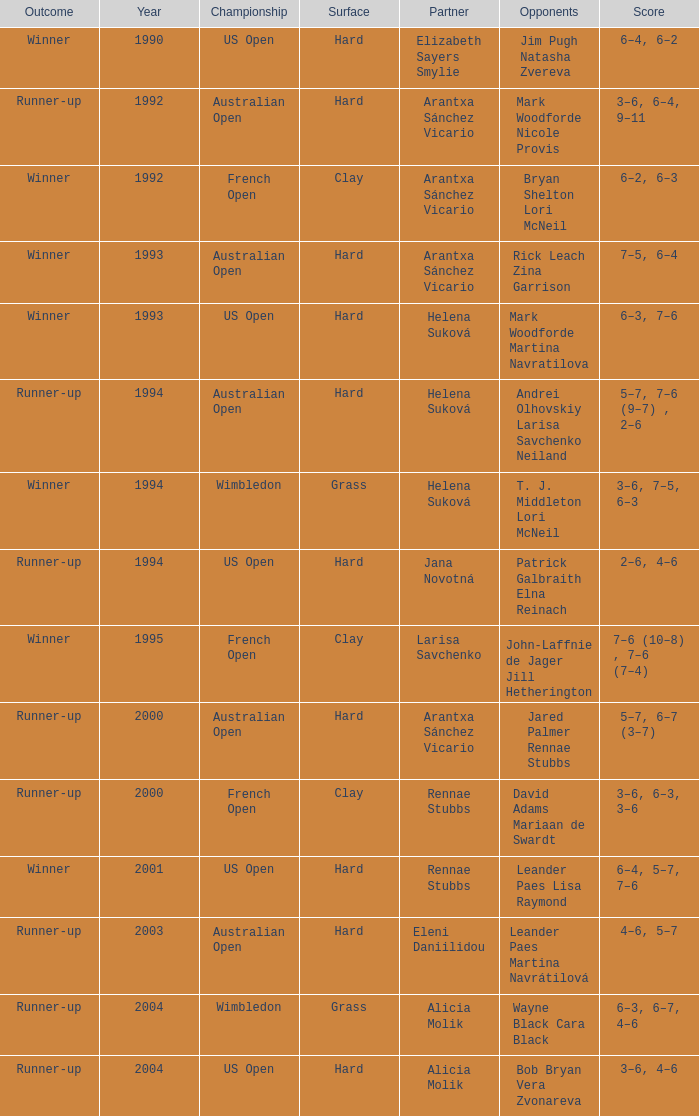Which Score has smaller than 1994, and a Partner of elizabeth sayers smylie? 6–4, 6–2. 